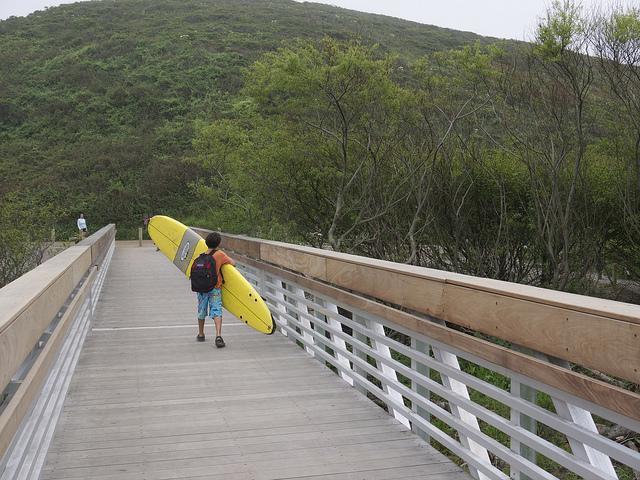How many donuts have no sprinkles?
Give a very brief answer. 0. 